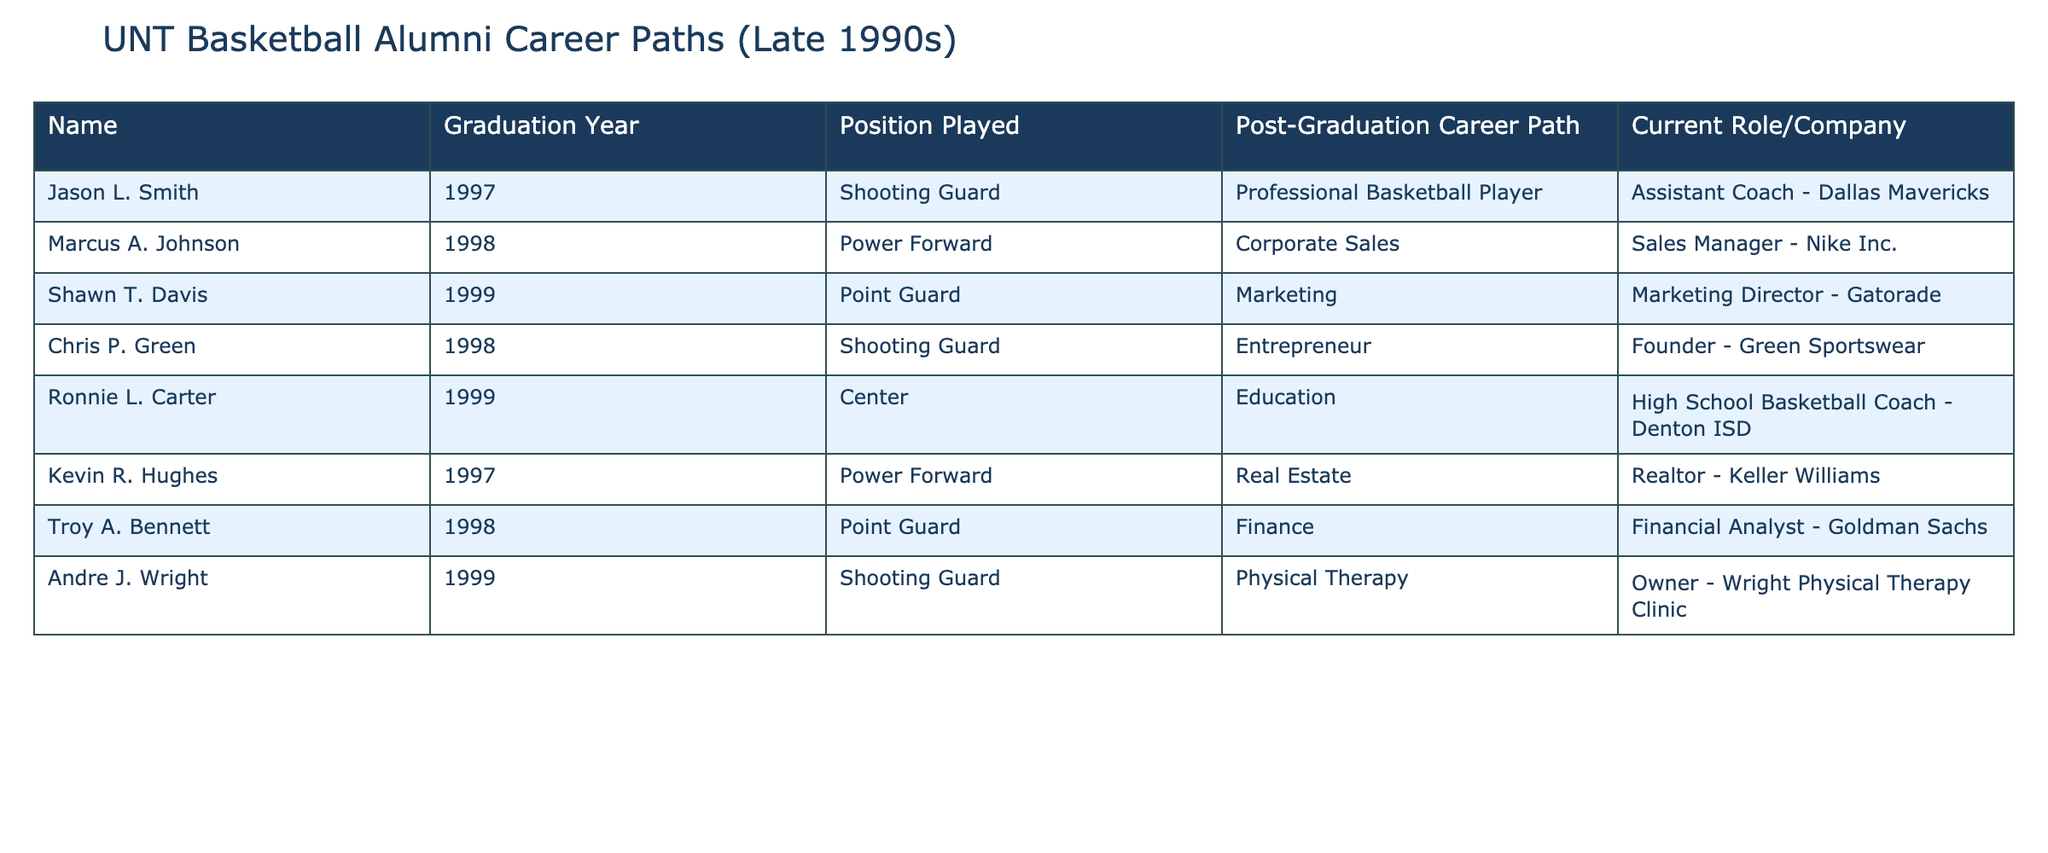What position did Jason L. Smith play? Jason L. Smith's record indicates that he played the position of Shooting Guard. This information can be found directly in the table under the "Position Played" column associated with his name.
Answer: Shooting Guard Which alumni are currently involved in education? To identify alumni in education, we look at the "Post-Graduation Career Path" column for any mentions of education-related roles. Ronnie L. Carter is listed as a High School Basketball Coach, which qualifies as being involved in education.
Answer: Ronnie L. Carter What is the most common post-graduation career path among these alumni? By examining the "Post-Graduation Career Path" column, we see that there are three distinct career paths: basketball player, corporate roles, and personal business roles. The most common role is unique (no repetitions), but "Professional Basketball Player" does appear once along with other unique roles. Therefore, we can conclude that there is no recurring path among the alumni.
Answer: No common path Did any alumni graduate in 1998 and later work in finance? Checking the table specifically for graduates from 1998 and their respective careers, we find Troy A. Bennett works as a Financial Analyst in finance. Thus, the answer to this question is confirmed to be true.
Answer: Yes What percentage of the alumni listed played the position of Point Guard? There are 8 alumni listed in total, with 2 students (Shawn T. Davis and Troy A. Bennett) playing the position of Point Guard. To calculate the percentage, we use the formula (Number of Point Guards / Total Alumni) * 100, which is (2/8) * 100 = 25%.
Answer: 25% Which companies employ alumni from this list? The "Current Role/Company" column provides information on where each alumni is currently employed. The companies mentioned in the table include Dallas Mavericks, Nike Inc., Gatorade, Green Sportswear, Denton ISD, Keller Williams, and Goldman Sachs.
Answer: Dallas Mavericks, Nike Inc., Gatorade, Green Sportswear, Denton ISD, Keller Williams, Goldman Sachs If we consider the alumni who are business owners, what is their most common career path? In the table, there’s one alumni listed as a business owner: Chris P. Green (Founder - Green Sportswear) and Andre J. Wright (Owner - Wright Physical Therapy Clinic). Thus, while both share the owner title, they belong to different sectors, indicating no prevailing career path among them. The most common role for them is "Owner."
Answer: Owner How many alumni switched from sports to corporate sales after graduation? Looking at the table, Marcus A. Johnson is the sole alumni who switched from sports (Power Forward) to Corporate Sales (Sales Manager - Nike Inc.). Therefore, considering the count, it is evident that only one alumnus made this specific switch.
Answer: One 